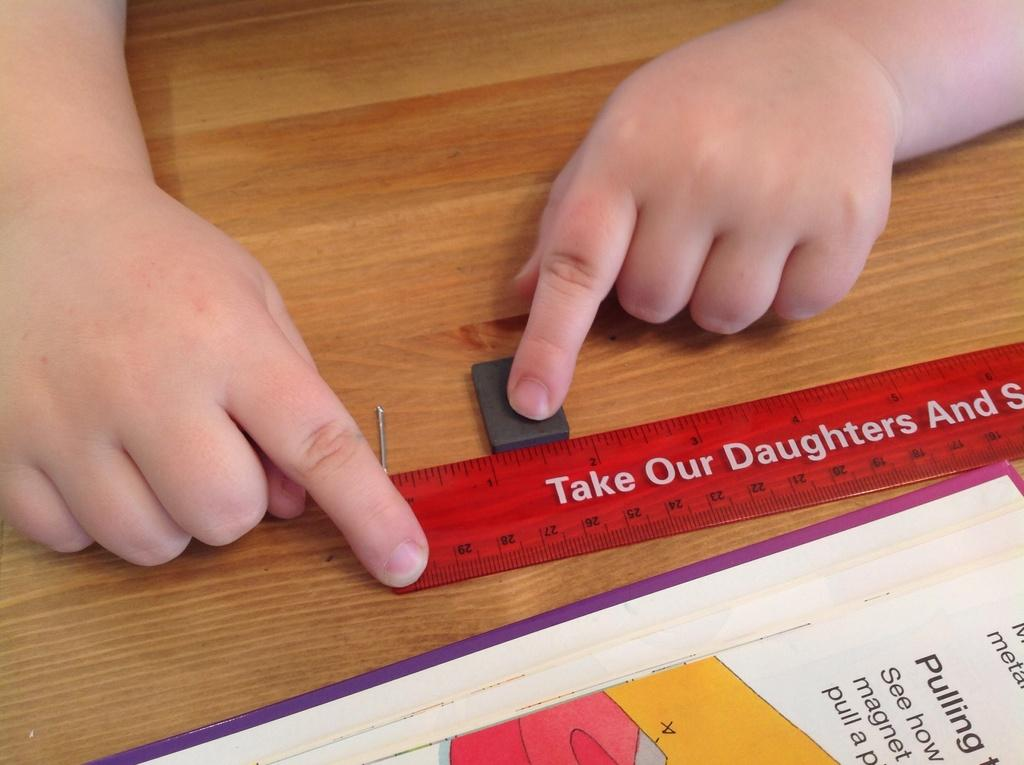Provide a one-sentence caption for the provided image. A red ruler is on a table that says, "Take our daughters" in white letters. 